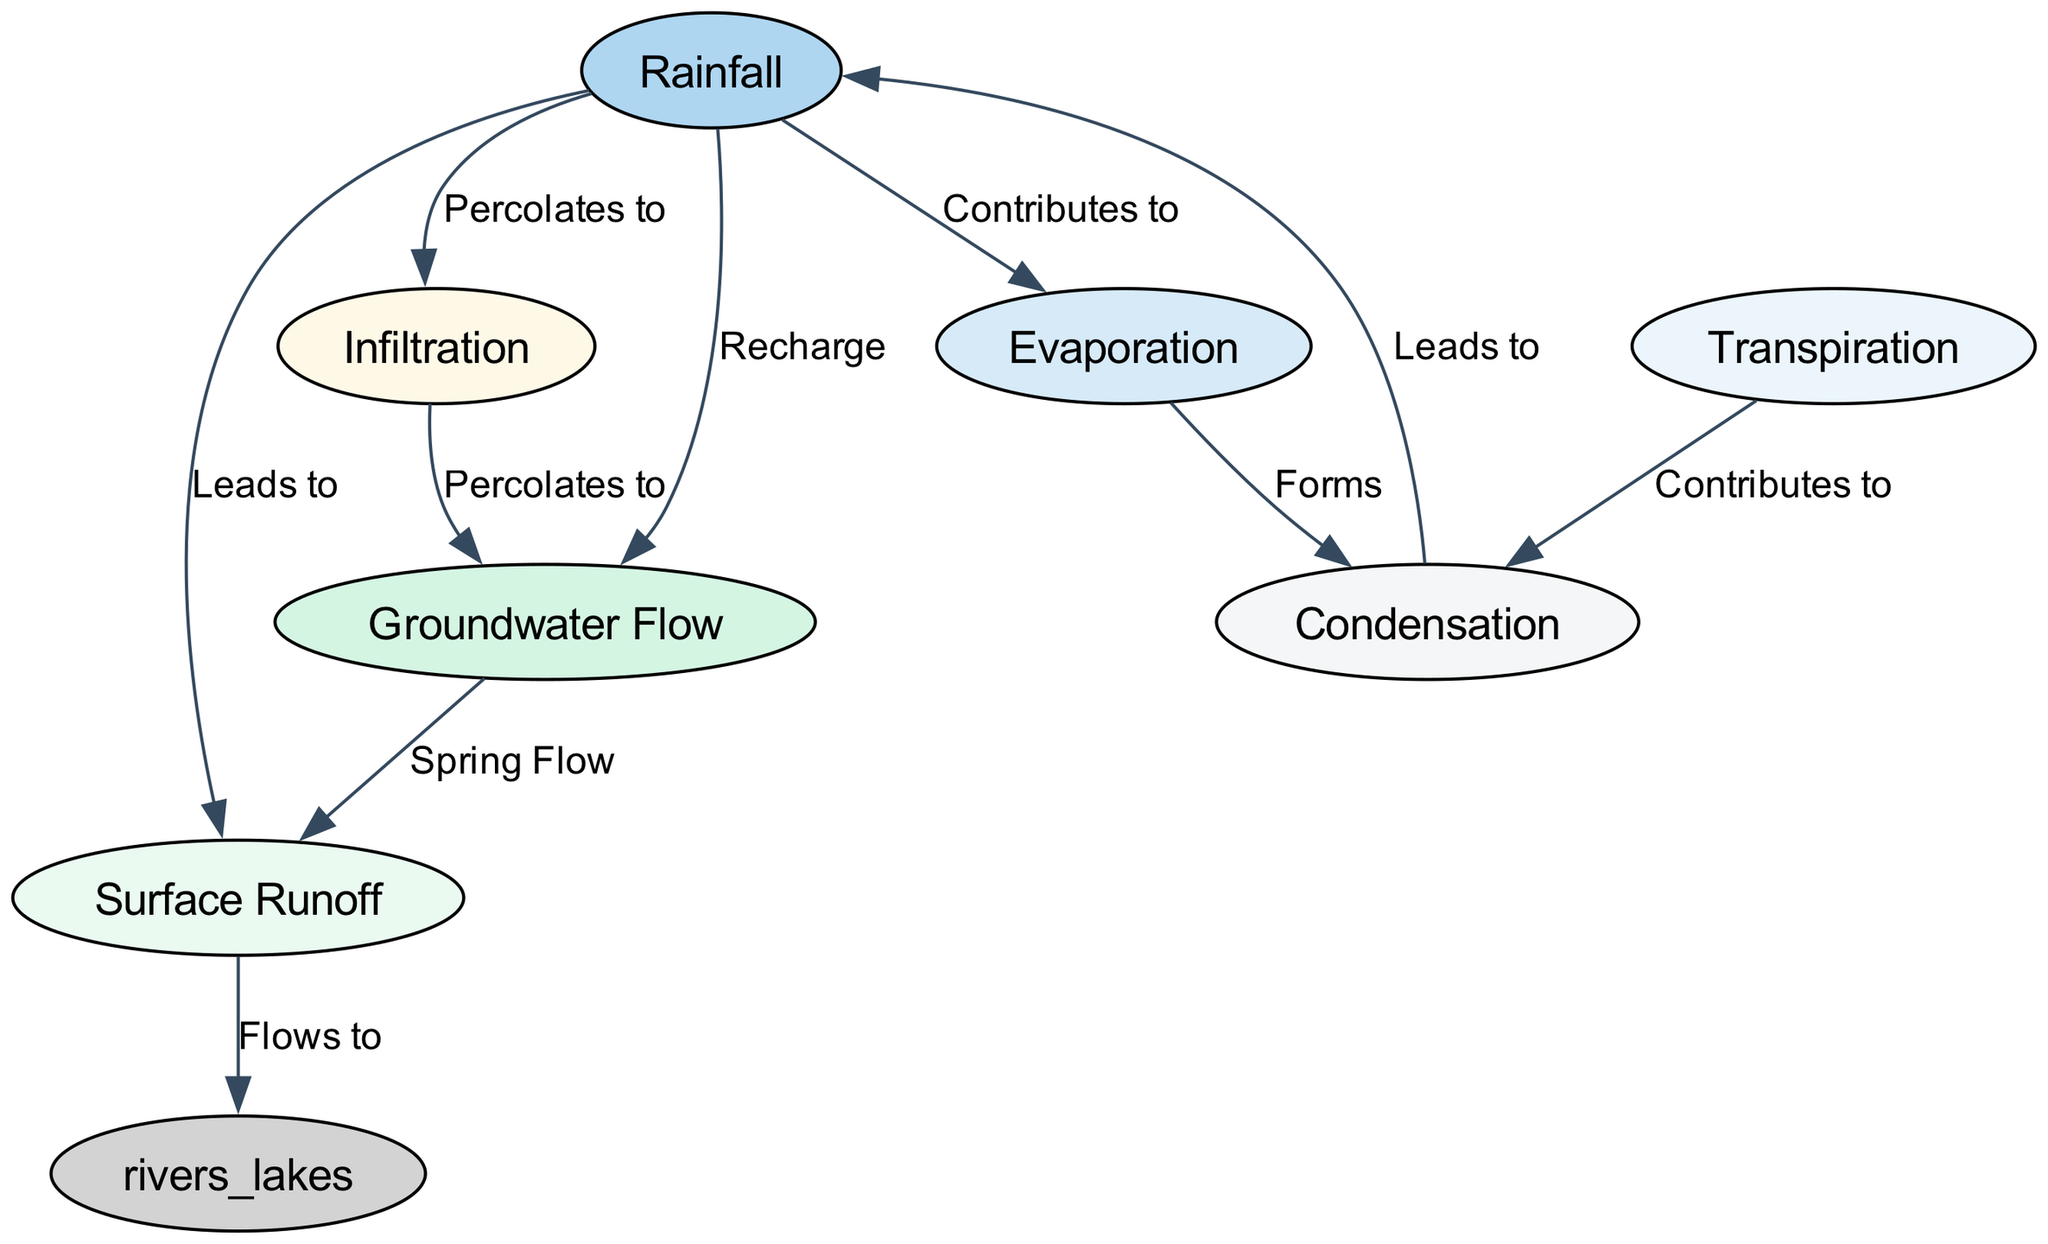What are the main components of the water cycle in Loresho? The diagram lists several nodes representing components of the water cycle: Rainfall, Evaporation, Transpiration, Condensation, Groundwater Flow, Surface Runoff, and Infiltration.
Answer: Rainfall, Evaporation, Transpiration, Condensation, Groundwater Flow, Surface Runoff, Infiltration How many edges are there in the diagram? By counting the connections (edges) in the diagram, we see that there are a total of 9 edges linking the various components.
Answer: 9 What does rainfall lead to in the water cycle? According to the diagram, rainfall leads to Surface Runoff and also contributes to Evaporation; it also percolates to Infiltration and recharges Groundwater Flow.
Answer: Surface Runoff, Evaporation, Infiltration, Groundwater Flow Which process contributes to condensation besides evaporation? The diagram indicates that Transpiration is another process that contributes to Condensation in the water cycle.
Answer: Transpiration How does groundwater flow relate to surface runoff? Analyzing the connections in the diagram, we see that Groundwater Flow contributes to Surface Runoff through Spring Flow, indicating how underground water can surface and contribute to runoff.
Answer: Spring Flow What process occurs after condensation according to the diagram? The diagram shows that after Condensation, the next process is Rainfall, linking these two components in a cyclical manner.
Answer: Rainfall Which two processes involve water moving through soil or land in Loresho? The processes of Infiltration and Groundwater Flow both involve the movement of water through soil or land, which can be tracked in the diagram through their connections.
Answer: Infiltration, Groundwater Flow 